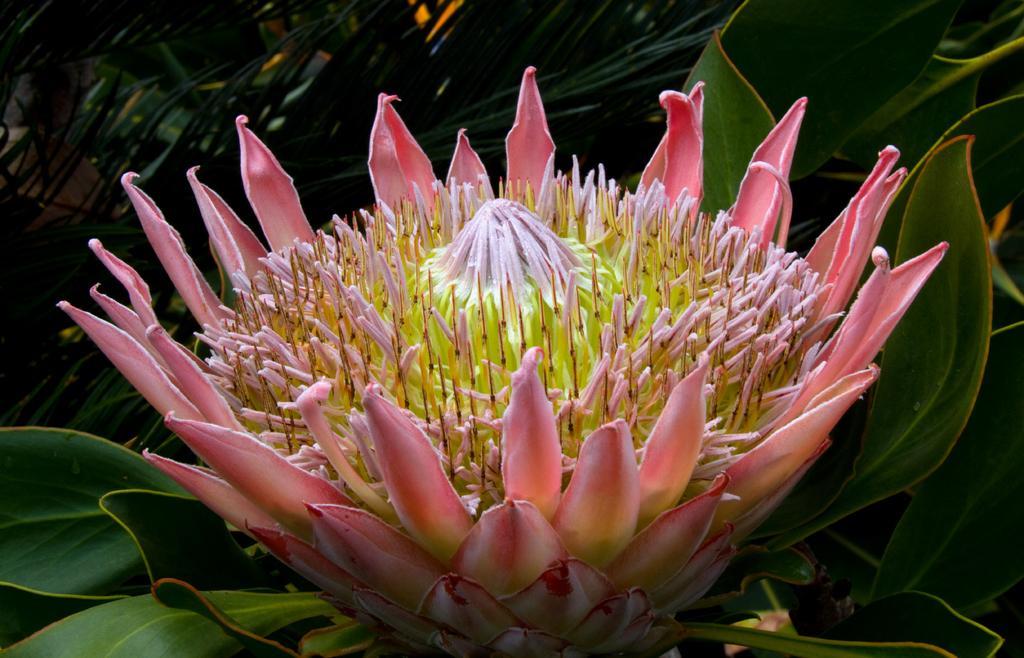How would you summarize this image in a sentence or two? In this picture we can see a flower, few leaves and a plant in the background. 